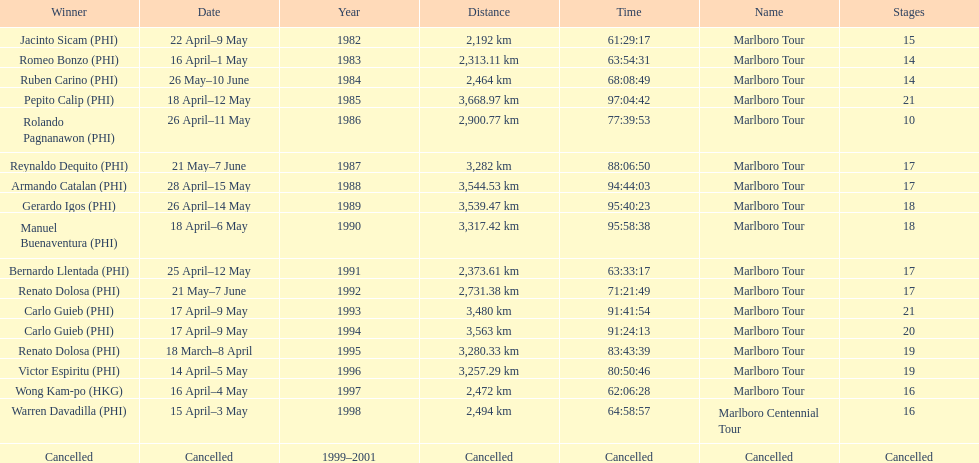What was the overall count of victors before the tour was called off? 17. 